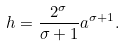Convert formula to latex. <formula><loc_0><loc_0><loc_500><loc_500>h = \frac { 2 ^ { \sigma } } { \sigma + 1 } a ^ { \sigma + 1 } .</formula> 